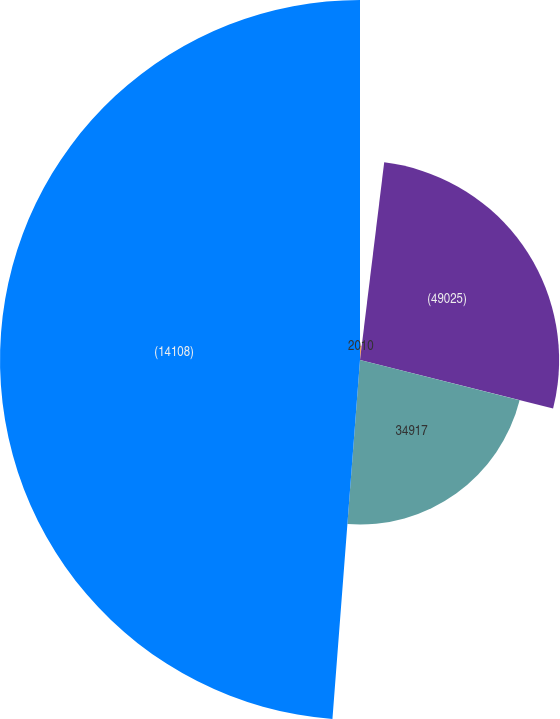Convert chart to OTSL. <chart><loc_0><loc_0><loc_500><loc_500><pie_chart><fcel>2010<fcel>(49025)<fcel>34917<fcel>(14108)<nl><fcel>1.94%<fcel>26.98%<fcel>22.3%<fcel>48.78%<nl></chart> 